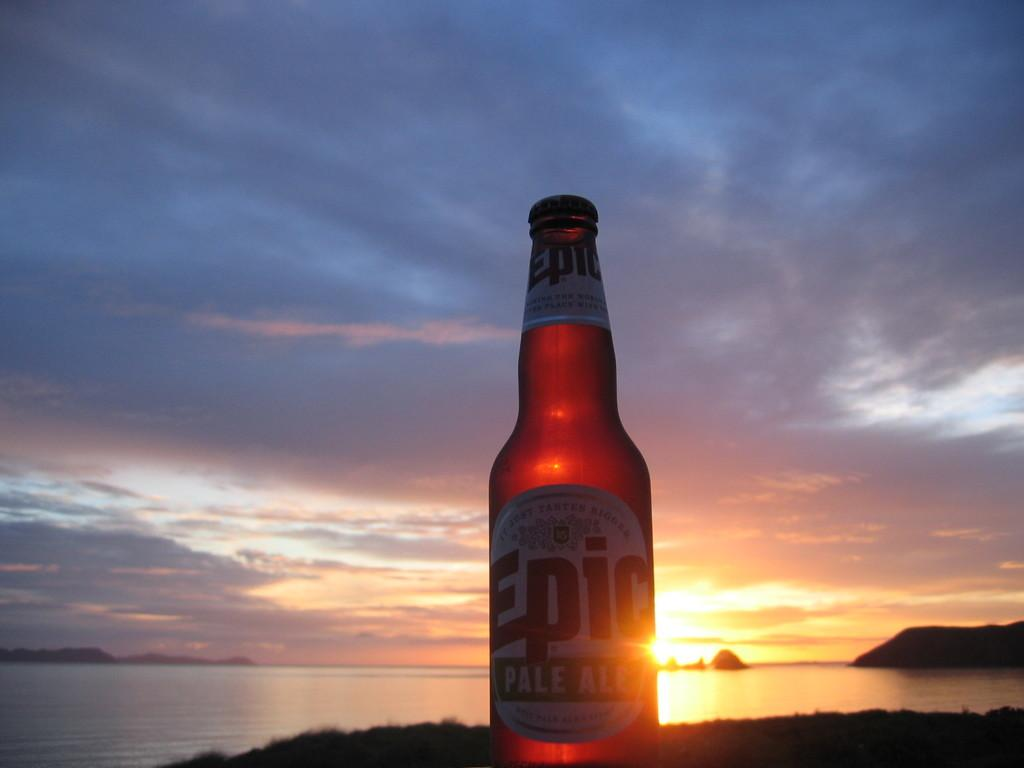<image>
Summarize the visual content of the image. An unopened bottle of Epic Pale Ale outside with a partly cloudy skies in the background. 